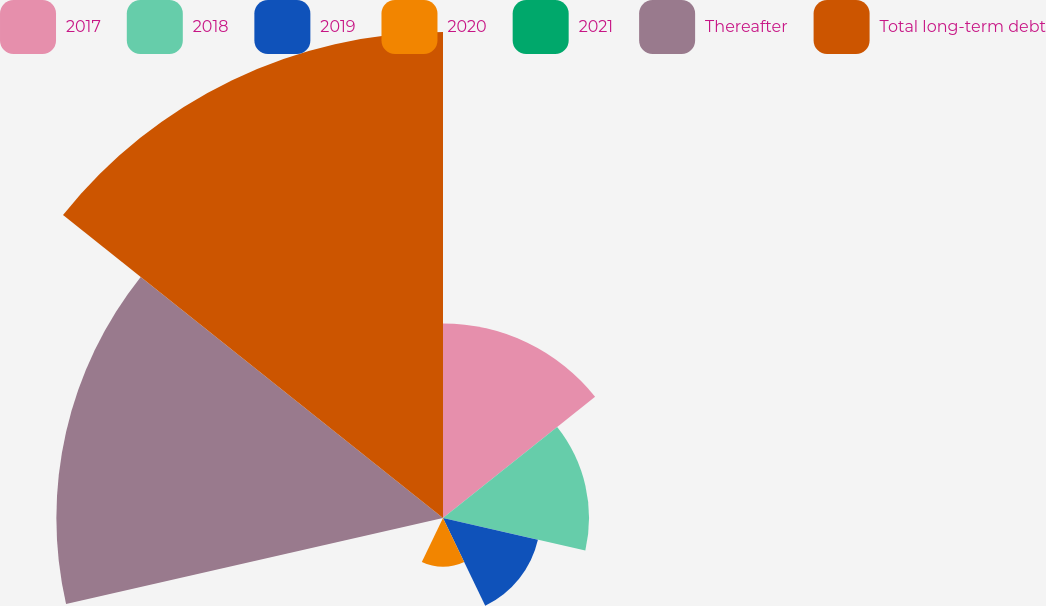Convert chart. <chart><loc_0><loc_0><loc_500><loc_500><pie_chart><fcel>2017<fcel>2018<fcel>2019<fcel>2020<fcel>2021<fcel>Thereafter<fcel>Total long-term debt<nl><fcel>14.31%<fcel>10.74%<fcel>7.16%<fcel>3.59%<fcel>0.02%<fcel>28.44%<fcel>35.75%<nl></chart> 